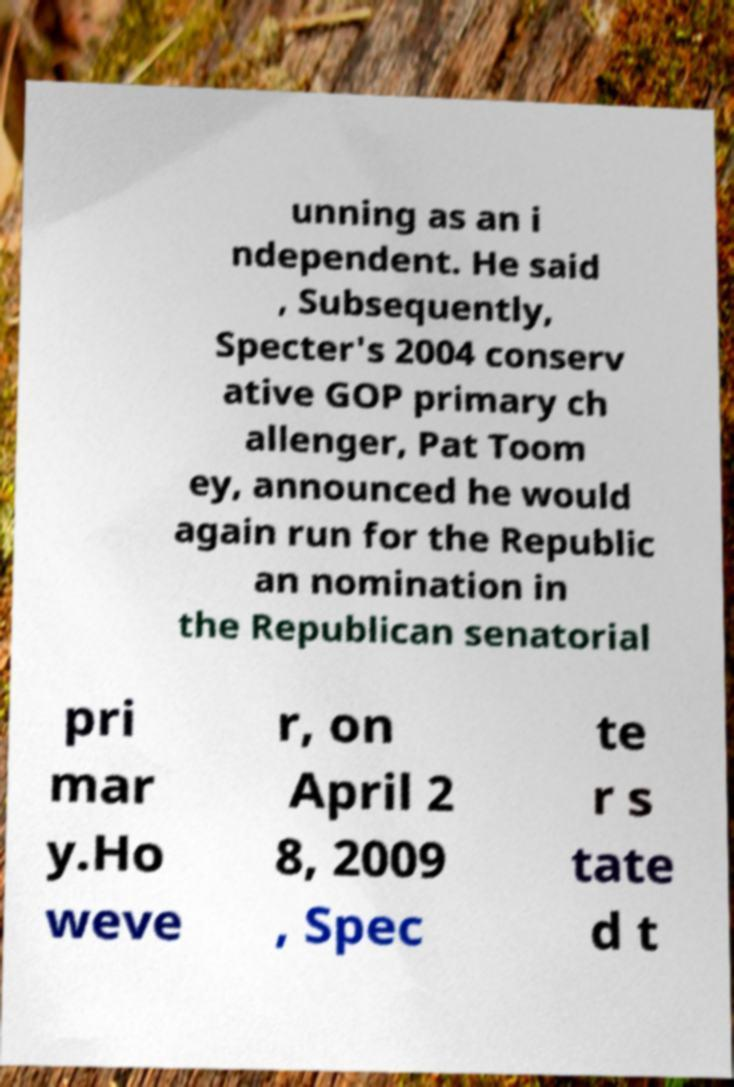Can you accurately transcribe the text from the provided image for me? unning as an i ndependent. He said , Subsequently, Specter's 2004 conserv ative GOP primary ch allenger, Pat Toom ey, announced he would again run for the Republic an nomination in the Republican senatorial pri mar y.Ho weve r, on April 2 8, 2009 , Spec te r s tate d t 